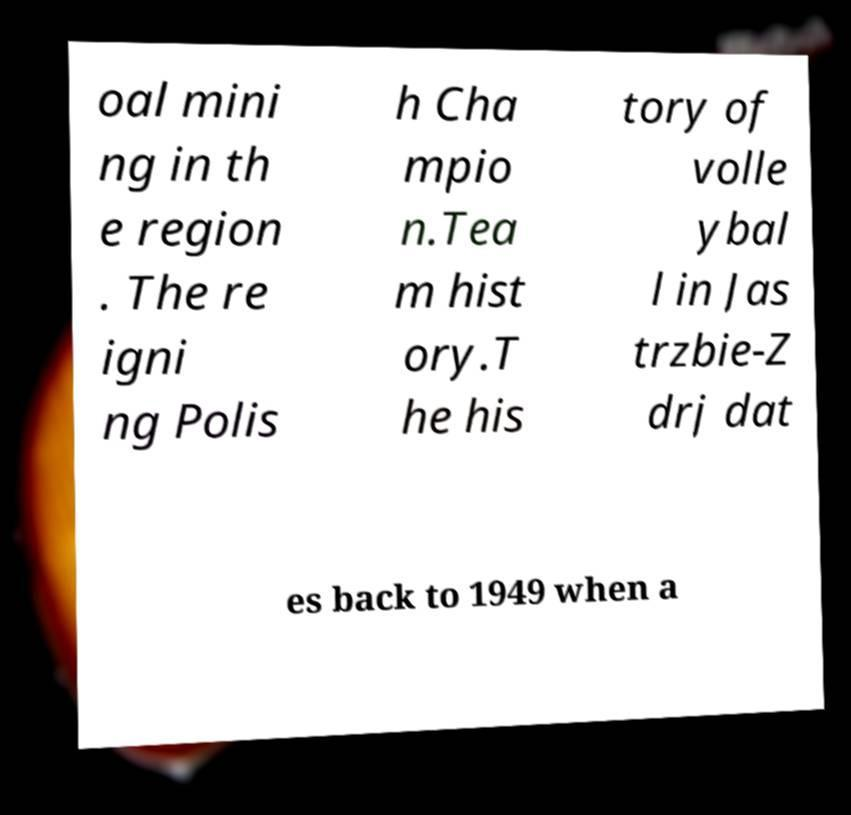Could you extract and type out the text from this image? oal mini ng in th e region . The re igni ng Polis h Cha mpio n.Tea m hist ory.T he his tory of volle ybal l in Jas trzbie-Z drj dat es back to 1949 when a 